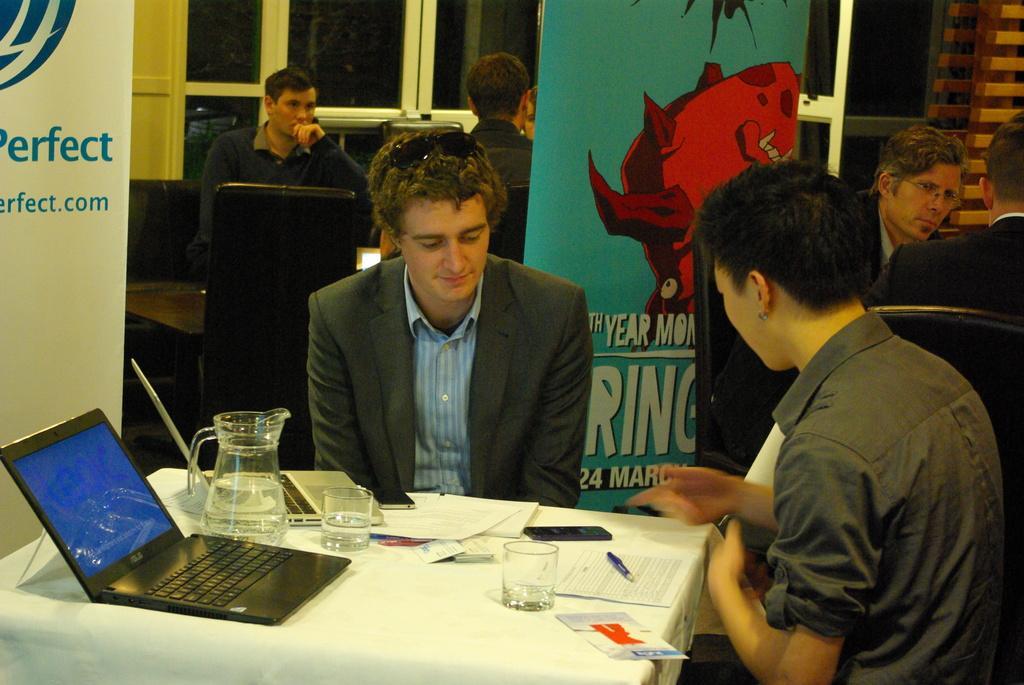Please provide a concise description of this image. In the picture it looks like an expo and there are different tables arranged in a room and in front of one of the table there are two men sitting and talking to each other,on the table there are two laptops,a jug,two glasses,some papers and mobile phones. Behind these two people there are two banners and in the same way there are some other people sitting around them,in the background there are many windows and doors. 